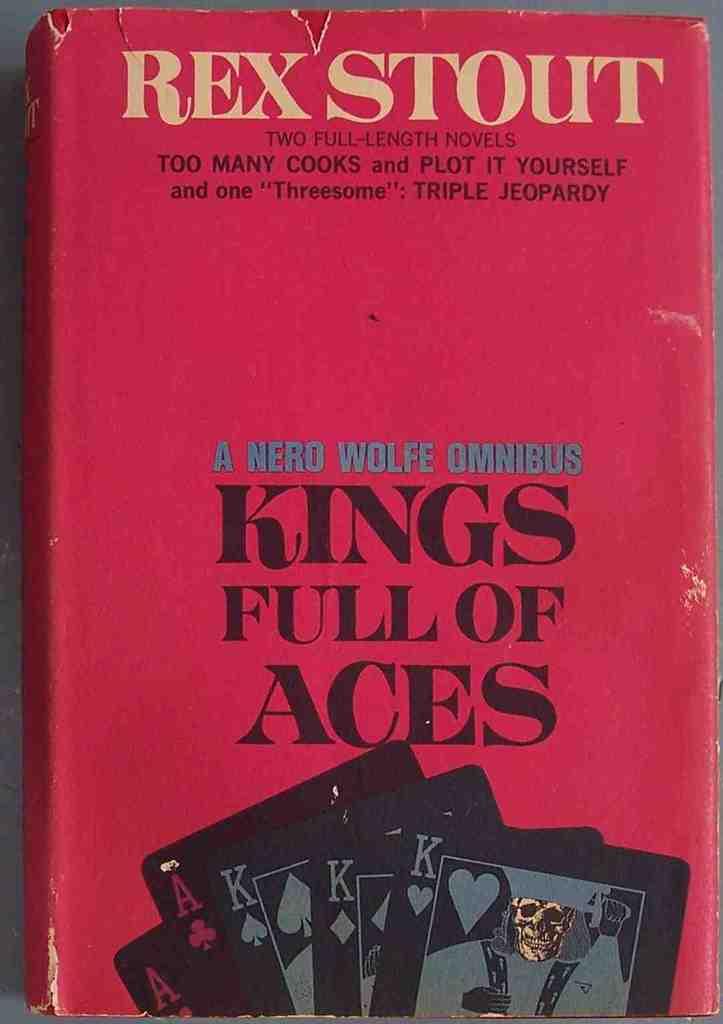Who is the author of the book?
Ensure brevity in your answer.  Rex stout. What is the title of the book?
Give a very brief answer. Kings full of aces. 